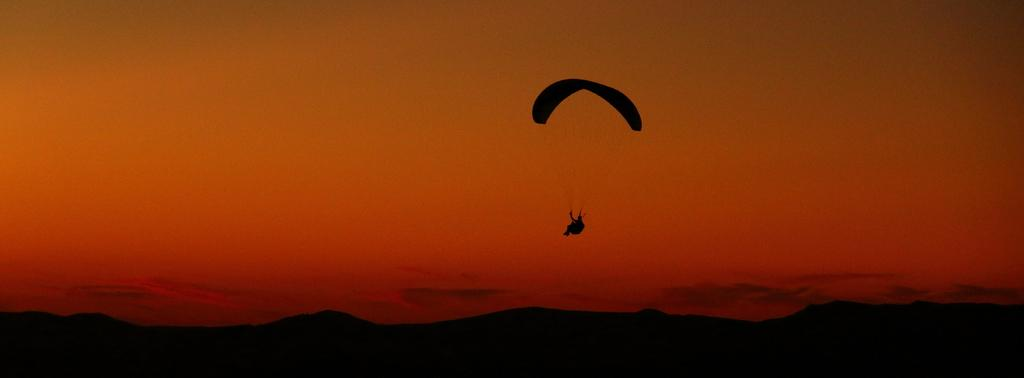What is the person holding in the image? The person is holding a hanger of a parachute. What is the parachute doing in the image? The parachute is in the air. What can be seen in the background of the image? There are mountains and the sky visible in the background of the image. What is the name of the bottle on the board in the image? There is no bottle or board present in the image. 